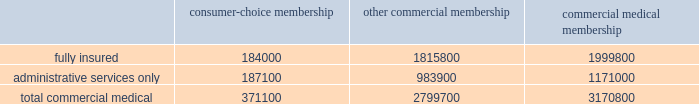Cost amount could have a material adverse effect on our business .
These changes may include , for example , an increase or reduction in the number of persons enrolled or eligible to enroll due to the federal government 2019s decision to increase or decrease u.s .
Military presence around the world .
In the event government reimbursements were to decline from projected amounts , our failure to reduce the health care costs associated with these programs could have a material adverse effect on our business .
During 2004 , we completed a contractual transition of our tricare business .
On july 1 , 2004 , our regions 2 and 5 contract servicing approximately 1.1 million tricare members became part of the new north region , which was awarded to another contractor .
On august 1 , 2004 , our regions 3 and 4 contract became part of our new south region contract .
On november 1 , 2004 , the region 6 contract with approximately 1 million members became part of the south region contract .
The members added with the region 6 contract essentially offset the members lost four months earlier with the expiration of our regions 2 and 5 contract .
For the year ended december 31 , 2005 , tricare premium revenues were approximately $ 2.4 billion , or 16.9% ( 16.9 % ) of our total premiums and aso fees .
Part of the tricare transition during 2004 included the carve out of the tricare senior pharmacy and tricare for life program which we previously administered on as aso basis .
On june 1 , 2004 and august 1 , 2004 , administrative services under these programs were transferred to another contractor .
For the year ended december 31 , 2005 , tricare administrative services fees totaled $ 50.1 million , or 0.4% ( 0.4 % ) of our total premiums and aso fees .
Our products marketed to commercial segment employers and members consumer-choice products over the last several years , we have developed and offered various commercial products designed to provide options and choices to employers that are annually facing substantial premium increases driven by double-digit medical cost inflation .
These consumer-choice products , which can be offered on either a fully insured or aso basis , provided coverage to approximately 371100 members at december 31 , 2005 , representing approximately 11.7% ( 11.7 % ) of our total commercial medical membership as detailed below .
Consumer-choice membership other commercial membership commercial medical membership .
These products are often offered to employer groups as 201cbundles 201d , where the subscribers are offered various hmo and ppo options , with various employer contribution strategies as determined by the employer .
Paramount to our consumer-choice product strategy , we have developed a group of innovative consumer products , styled as 201csmart 201d products , that we believe will be a long-term solution for employers .
We believe this new generation of products provides more ( 1 ) choices for the individual consumer , ( 2 ) transparency of provider costs , and ( 3 ) benefit designs that engage consumers in the costs and effectiveness of health care choices .
Innovative tools and technology are available to assist consumers with these decisions , including the trade-offs between higher premiums and point-of-service costs at the time consumers choose their plans , and to suggest ways in which the consumers can maximize their individual benefits at the point they use their plans .
We believe that when consumers can make informed choices about the cost and effectiveness of their health care , a sustainable long term solution for employers can be realized .
Smart products , which accounted for approximately 65.1% ( 65.1 % ) of enrollment in all of our consumer-choice plans as of december 31 , 2005 , only are sold to employers who use humana as their sole health insurance carrier. .
What was the percent of the fully insured of the consumer-choice membership total? 
Computations: (184000 / 371100)
Answer: 0.49582. 